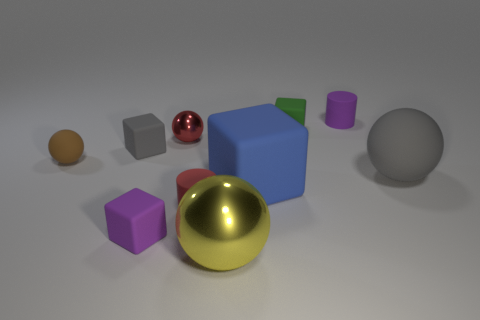What might be the purpose of arranging these objects together? The arrangement of these objects could serve an educational purpose, such as demonstrating shapes, colors, and materials in a visual manner for learning, or it could be a compositional study for an artist exploring the interaction of light and shadow on various geometric forms. 